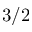<formula> <loc_0><loc_0><loc_500><loc_500>3 / 2</formula> 